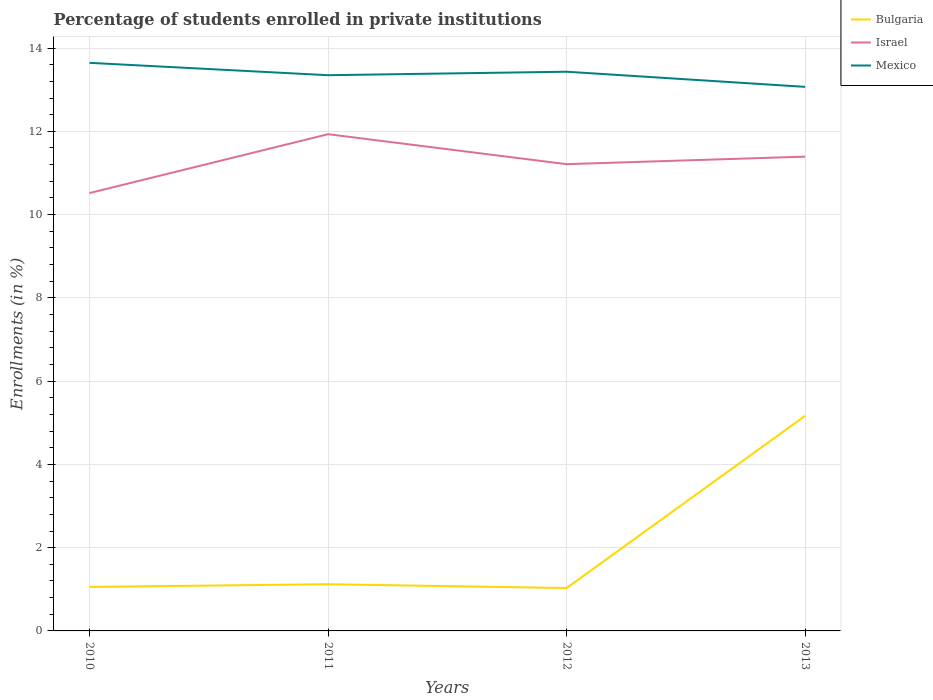How many different coloured lines are there?
Provide a succinct answer. 3. Does the line corresponding to Bulgaria intersect with the line corresponding to Mexico?
Provide a succinct answer. No. Across all years, what is the maximum percentage of trained teachers in Israel?
Make the answer very short. 10.52. What is the total percentage of trained teachers in Bulgaria in the graph?
Keep it short and to the point. -4.11. What is the difference between the highest and the second highest percentage of trained teachers in Israel?
Your answer should be very brief. 1.41. What is the difference between the highest and the lowest percentage of trained teachers in Israel?
Your answer should be very brief. 2. Where does the legend appear in the graph?
Offer a terse response. Top right. What is the title of the graph?
Offer a very short reply. Percentage of students enrolled in private institutions. What is the label or title of the Y-axis?
Your response must be concise. Enrollments (in %). What is the Enrollments (in %) in Bulgaria in 2010?
Offer a terse response. 1.06. What is the Enrollments (in %) of Israel in 2010?
Provide a short and direct response. 10.52. What is the Enrollments (in %) of Mexico in 2010?
Your answer should be compact. 13.65. What is the Enrollments (in %) in Bulgaria in 2011?
Your answer should be compact. 1.12. What is the Enrollments (in %) in Israel in 2011?
Your answer should be compact. 11.93. What is the Enrollments (in %) of Mexico in 2011?
Your answer should be compact. 13.35. What is the Enrollments (in %) of Bulgaria in 2012?
Give a very brief answer. 1.03. What is the Enrollments (in %) of Israel in 2012?
Keep it short and to the point. 11.21. What is the Enrollments (in %) of Mexico in 2012?
Your answer should be compact. 13.43. What is the Enrollments (in %) in Bulgaria in 2013?
Offer a very short reply. 5.17. What is the Enrollments (in %) in Israel in 2013?
Provide a short and direct response. 11.39. What is the Enrollments (in %) in Mexico in 2013?
Make the answer very short. 13.07. Across all years, what is the maximum Enrollments (in %) in Bulgaria?
Provide a short and direct response. 5.17. Across all years, what is the maximum Enrollments (in %) in Israel?
Give a very brief answer. 11.93. Across all years, what is the maximum Enrollments (in %) in Mexico?
Your answer should be very brief. 13.65. Across all years, what is the minimum Enrollments (in %) in Bulgaria?
Ensure brevity in your answer.  1.03. Across all years, what is the minimum Enrollments (in %) in Israel?
Your answer should be very brief. 10.52. Across all years, what is the minimum Enrollments (in %) of Mexico?
Give a very brief answer. 13.07. What is the total Enrollments (in %) of Bulgaria in the graph?
Keep it short and to the point. 8.38. What is the total Enrollments (in %) in Israel in the graph?
Provide a short and direct response. 45.05. What is the total Enrollments (in %) of Mexico in the graph?
Offer a very short reply. 53.49. What is the difference between the Enrollments (in %) in Bulgaria in 2010 and that in 2011?
Give a very brief answer. -0.06. What is the difference between the Enrollments (in %) in Israel in 2010 and that in 2011?
Give a very brief answer. -1.41. What is the difference between the Enrollments (in %) in Mexico in 2010 and that in 2011?
Provide a succinct answer. 0.3. What is the difference between the Enrollments (in %) in Bulgaria in 2010 and that in 2012?
Provide a succinct answer. 0.03. What is the difference between the Enrollments (in %) of Israel in 2010 and that in 2012?
Make the answer very short. -0.69. What is the difference between the Enrollments (in %) in Mexico in 2010 and that in 2012?
Your answer should be very brief. 0.21. What is the difference between the Enrollments (in %) in Bulgaria in 2010 and that in 2013?
Offer a terse response. -4.11. What is the difference between the Enrollments (in %) in Israel in 2010 and that in 2013?
Offer a terse response. -0.88. What is the difference between the Enrollments (in %) of Mexico in 2010 and that in 2013?
Your answer should be compact. 0.58. What is the difference between the Enrollments (in %) of Bulgaria in 2011 and that in 2012?
Your answer should be compact. 0.09. What is the difference between the Enrollments (in %) of Israel in 2011 and that in 2012?
Make the answer very short. 0.72. What is the difference between the Enrollments (in %) of Mexico in 2011 and that in 2012?
Make the answer very short. -0.08. What is the difference between the Enrollments (in %) in Bulgaria in 2011 and that in 2013?
Ensure brevity in your answer.  -4.05. What is the difference between the Enrollments (in %) of Israel in 2011 and that in 2013?
Make the answer very short. 0.54. What is the difference between the Enrollments (in %) of Mexico in 2011 and that in 2013?
Give a very brief answer. 0.28. What is the difference between the Enrollments (in %) of Bulgaria in 2012 and that in 2013?
Your answer should be very brief. -4.14. What is the difference between the Enrollments (in %) of Israel in 2012 and that in 2013?
Offer a very short reply. -0.18. What is the difference between the Enrollments (in %) in Mexico in 2012 and that in 2013?
Keep it short and to the point. 0.36. What is the difference between the Enrollments (in %) of Bulgaria in 2010 and the Enrollments (in %) of Israel in 2011?
Provide a succinct answer. -10.87. What is the difference between the Enrollments (in %) in Bulgaria in 2010 and the Enrollments (in %) in Mexico in 2011?
Your answer should be very brief. -12.29. What is the difference between the Enrollments (in %) of Israel in 2010 and the Enrollments (in %) of Mexico in 2011?
Keep it short and to the point. -2.83. What is the difference between the Enrollments (in %) of Bulgaria in 2010 and the Enrollments (in %) of Israel in 2012?
Offer a terse response. -10.15. What is the difference between the Enrollments (in %) of Bulgaria in 2010 and the Enrollments (in %) of Mexico in 2012?
Ensure brevity in your answer.  -12.37. What is the difference between the Enrollments (in %) of Israel in 2010 and the Enrollments (in %) of Mexico in 2012?
Give a very brief answer. -2.91. What is the difference between the Enrollments (in %) in Bulgaria in 2010 and the Enrollments (in %) in Israel in 2013?
Your answer should be compact. -10.33. What is the difference between the Enrollments (in %) in Bulgaria in 2010 and the Enrollments (in %) in Mexico in 2013?
Give a very brief answer. -12.01. What is the difference between the Enrollments (in %) of Israel in 2010 and the Enrollments (in %) of Mexico in 2013?
Your response must be concise. -2.55. What is the difference between the Enrollments (in %) in Bulgaria in 2011 and the Enrollments (in %) in Israel in 2012?
Offer a very short reply. -10.09. What is the difference between the Enrollments (in %) of Bulgaria in 2011 and the Enrollments (in %) of Mexico in 2012?
Offer a very short reply. -12.31. What is the difference between the Enrollments (in %) in Israel in 2011 and the Enrollments (in %) in Mexico in 2012?
Ensure brevity in your answer.  -1.5. What is the difference between the Enrollments (in %) of Bulgaria in 2011 and the Enrollments (in %) of Israel in 2013?
Ensure brevity in your answer.  -10.27. What is the difference between the Enrollments (in %) in Bulgaria in 2011 and the Enrollments (in %) in Mexico in 2013?
Provide a short and direct response. -11.95. What is the difference between the Enrollments (in %) of Israel in 2011 and the Enrollments (in %) of Mexico in 2013?
Ensure brevity in your answer.  -1.14. What is the difference between the Enrollments (in %) of Bulgaria in 2012 and the Enrollments (in %) of Israel in 2013?
Your answer should be very brief. -10.36. What is the difference between the Enrollments (in %) in Bulgaria in 2012 and the Enrollments (in %) in Mexico in 2013?
Ensure brevity in your answer.  -12.04. What is the difference between the Enrollments (in %) in Israel in 2012 and the Enrollments (in %) in Mexico in 2013?
Offer a very short reply. -1.86. What is the average Enrollments (in %) of Bulgaria per year?
Provide a succinct answer. 2.09. What is the average Enrollments (in %) in Israel per year?
Ensure brevity in your answer.  11.26. What is the average Enrollments (in %) of Mexico per year?
Offer a very short reply. 13.37. In the year 2010, what is the difference between the Enrollments (in %) of Bulgaria and Enrollments (in %) of Israel?
Provide a succinct answer. -9.46. In the year 2010, what is the difference between the Enrollments (in %) in Bulgaria and Enrollments (in %) in Mexico?
Make the answer very short. -12.59. In the year 2010, what is the difference between the Enrollments (in %) in Israel and Enrollments (in %) in Mexico?
Provide a short and direct response. -3.13. In the year 2011, what is the difference between the Enrollments (in %) of Bulgaria and Enrollments (in %) of Israel?
Ensure brevity in your answer.  -10.81. In the year 2011, what is the difference between the Enrollments (in %) of Bulgaria and Enrollments (in %) of Mexico?
Give a very brief answer. -12.23. In the year 2011, what is the difference between the Enrollments (in %) in Israel and Enrollments (in %) in Mexico?
Make the answer very short. -1.42. In the year 2012, what is the difference between the Enrollments (in %) of Bulgaria and Enrollments (in %) of Israel?
Ensure brevity in your answer.  -10.18. In the year 2012, what is the difference between the Enrollments (in %) of Bulgaria and Enrollments (in %) of Mexico?
Provide a succinct answer. -12.4. In the year 2012, what is the difference between the Enrollments (in %) in Israel and Enrollments (in %) in Mexico?
Provide a short and direct response. -2.22. In the year 2013, what is the difference between the Enrollments (in %) in Bulgaria and Enrollments (in %) in Israel?
Ensure brevity in your answer.  -6.22. In the year 2013, what is the difference between the Enrollments (in %) of Bulgaria and Enrollments (in %) of Mexico?
Offer a very short reply. -7.9. In the year 2013, what is the difference between the Enrollments (in %) of Israel and Enrollments (in %) of Mexico?
Make the answer very short. -1.68. What is the ratio of the Enrollments (in %) of Bulgaria in 2010 to that in 2011?
Provide a succinct answer. 0.94. What is the ratio of the Enrollments (in %) in Israel in 2010 to that in 2011?
Provide a succinct answer. 0.88. What is the ratio of the Enrollments (in %) of Mexico in 2010 to that in 2011?
Provide a succinct answer. 1.02. What is the ratio of the Enrollments (in %) of Bulgaria in 2010 to that in 2012?
Your answer should be compact. 1.03. What is the ratio of the Enrollments (in %) in Israel in 2010 to that in 2012?
Make the answer very short. 0.94. What is the ratio of the Enrollments (in %) of Mexico in 2010 to that in 2012?
Your answer should be compact. 1.02. What is the ratio of the Enrollments (in %) of Bulgaria in 2010 to that in 2013?
Ensure brevity in your answer.  0.2. What is the ratio of the Enrollments (in %) in Israel in 2010 to that in 2013?
Ensure brevity in your answer.  0.92. What is the ratio of the Enrollments (in %) in Mexico in 2010 to that in 2013?
Keep it short and to the point. 1.04. What is the ratio of the Enrollments (in %) in Bulgaria in 2011 to that in 2012?
Your answer should be compact. 1.09. What is the ratio of the Enrollments (in %) of Israel in 2011 to that in 2012?
Offer a very short reply. 1.06. What is the ratio of the Enrollments (in %) in Mexico in 2011 to that in 2012?
Your answer should be compact. 0.99. What is the ratio of the Enrollments (in %) of Bulgaria in 2011 to that in 2013?
Keep it short and to the point. 0.22. What is the ratio of the Enrollments (in %) of Israel in 2011 to that in 2013?
Give a very brief answer. 1.05. What is the ratio of the Enrollments (in %) in Mexico in 2011 to that in 2013?
Your response must be concise. 1.02. What is the ratio of the Enrollments (in %) of Bulgaria in 2012 to that in 2013?
Your response must be concise. 0.2. What is the ratio of the Enrollments (in %) of Israel in 2012 to that in 2013?
Make the answer very short. 0.98. What is the ratio of the Enrollments (in %) of Mexico in 2012 to that in 2013?
Your answer should be compact. 1.03. What is the difference between the highest and the second highest Enrollments (in %) of Bulgaria?
Provide a short and direct response. 4.05. What is the difference between the highest and the second highest Enrollments (in %) in Israel?
Offer a terse response. 0.54. What is the difference between the highest and the second highest Enrollments (in %) of Mexico?
Give a very brief answer. 0.21. What is the difference between the highest and the lowest Enrollments (in %) in Bulgaria?
Your answer should be compact. 4.14. What is the difference between the highest and the lowest Enrollments (in %) of Israel?
Your response must be concise. 1.41. What is the difference between the highest and the lowest Enrollments (in %) in Mexico?
Your answer should be compact. 0.58. 